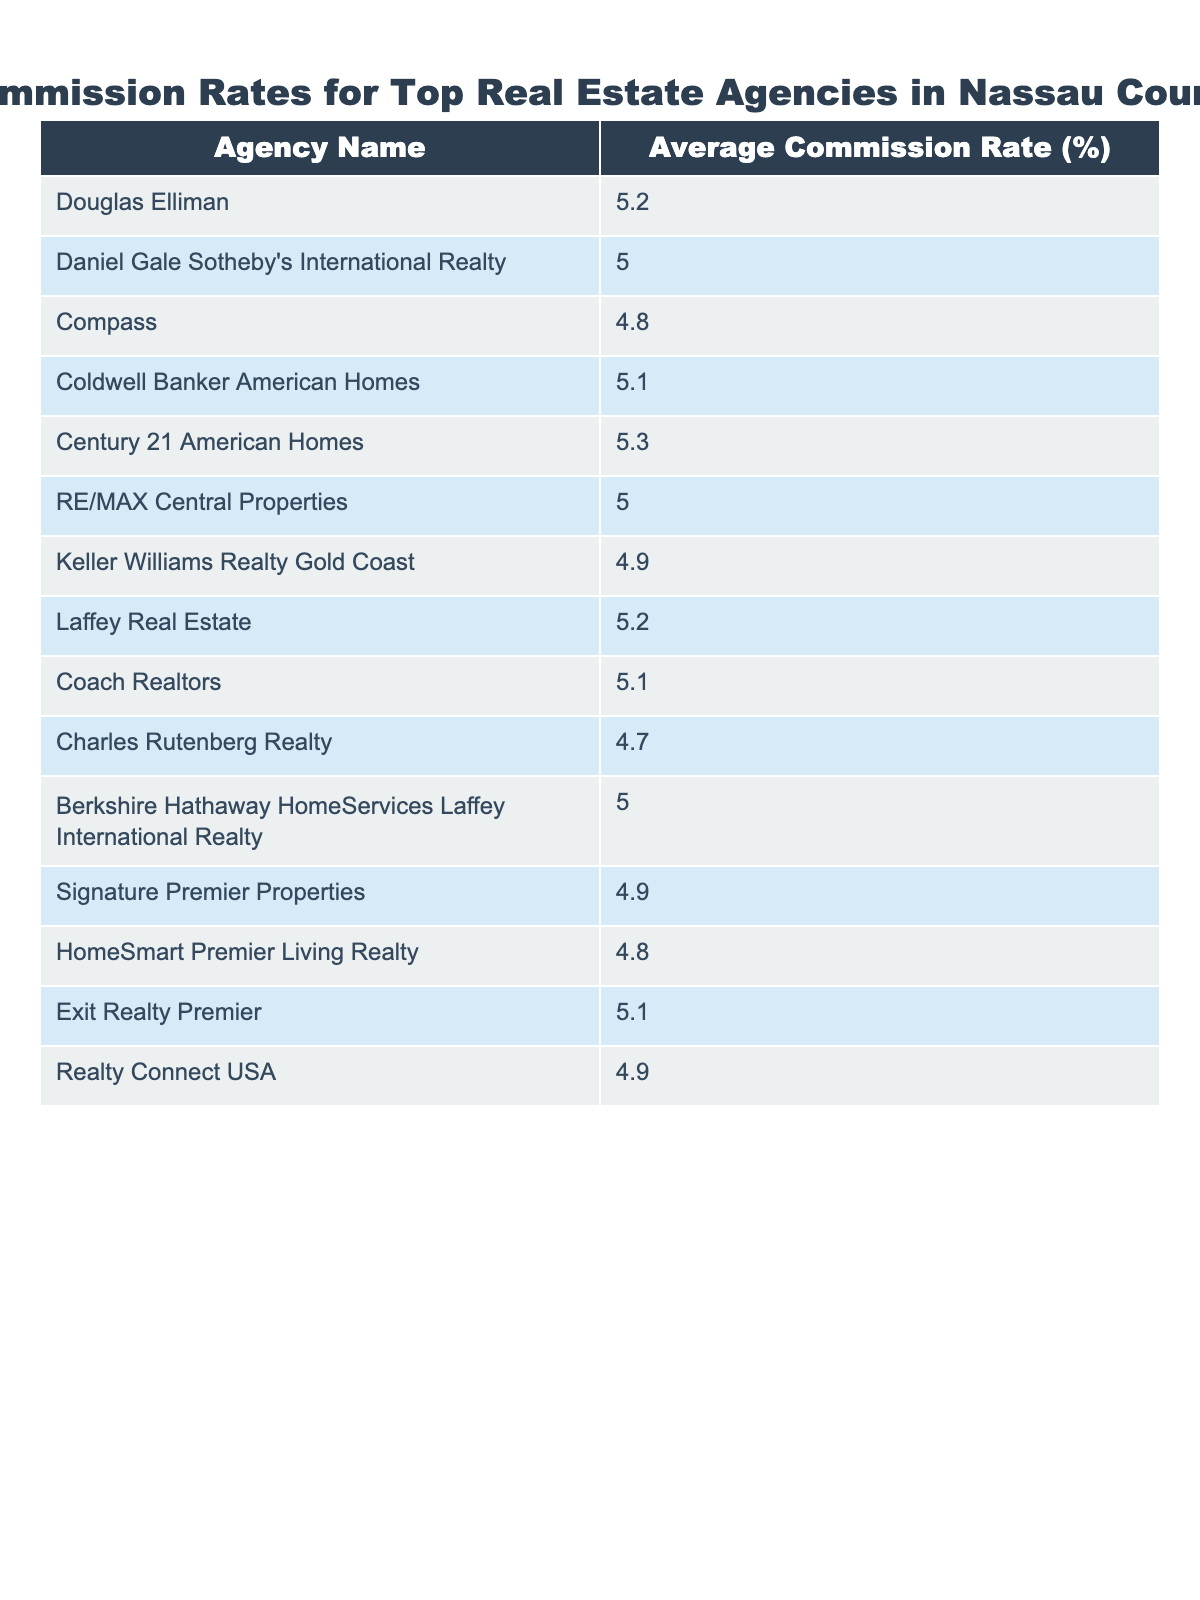What is the average commission rate for Douglas Elliman? The table shows that the average commission rate for Douglas Elliman is listed under its name, which is 5.2%.
Answer: 5.2% Which agency has the lowest commission rate? By examining the average commission rates, Charles Rutenberg Realty has the lowest rate at 4.7%.
Answer: 4.7% What is the difference in commission rates between Coldwell Banker American Homes and Keller Williams Realty Gold Coast? The rate for Coldwell Banker American Homes is 5.1% and Keller Williams Realty Gold Coast is 4.9%. The difference is calculated as 5.1% - 4.9% = 0.2%.
Answer: 0.2% Which agencies have a commission rate of 5.0%? Looking through the table, the agencies with a commission rate of 5.0% are Daniel Gale Sotheby's International Realty, RE/MAX Central Properties, and Berkshire Hathaway HomeServices Laffey International Realty.
Answer: Three agencies What is the average commission rate of all agencies listed in the table? To find the average, we sum up all the average commission rates (5.2 + 5.0 + 4.8 + 5.1 + 5.3 + 5.0 + 4.9 + 5.2 + 5.1 + 4.7 + 5.0 + 4.9 + 4.8 + 5.1 + 4.9) which equals 75.7, and divide by the number of agencies (15). So, 75.7 / 15 = 5.04%.
Answer: 5.04% Is it true that there are more agencies with a commission rate above 5% than below? From the table, we can count the agencies with rates above 5% (Douglas Elliman, Coldwell Banker American Homes, Century 21 American Homes, Laffey Real Estate, Coach Realtors, Exit Realty Premier) which totals 6, whereas those below 5% are Compass, Keller Williams Realty Gold Coast, Charles Rutenberg Realty, Signature Premier Properties, HomeSmart Premier Living Realty, and Realty Connect USA, totaling 6 as well. Hence, the statement is false.
Answer: False What is the total commission rate of the three highest agencies? The highest rates are from Century 21 American Homes (5.3%), Douglas Elliman (5.2%), and Laffey Real Estate (5.2%). Their total is calculated as 5.3% + 5.2% + 5.2% = 15.7%.
Answer: 15.7% In how many agencies do the commission rates equal or exceed 5.1%? The agencies with rates of 5.1% or higher are Douglas Elliman, Coldwell Banker American Homes, Century 21 American Homes, Laffey Real Estate, Coach Realtors, Exit Realty Premier, and one agency at 5.2% (7 total).
Answer: 7 agencies 